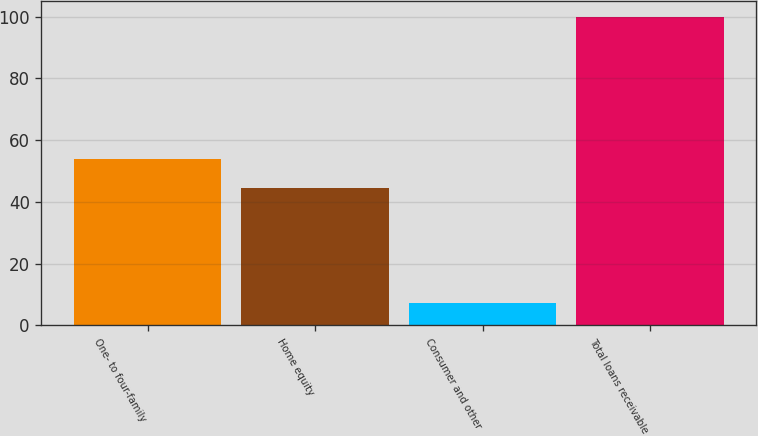Convert chart to OTSL. <chart><loc_0><loc_0><loc_500><loc_500><bar_chart><fcel>One- to four-family<fcel>Home equity<fcel>Consumer and other<fcel>Total loans receivable<nl><fcel>53.88<fcel>44.6<fcel>7.2<fcel>100<nl></chart> 